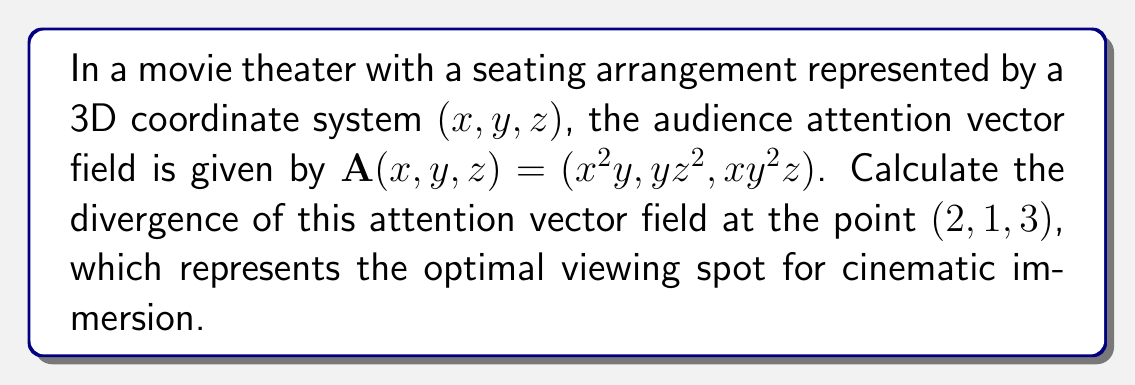What is the answer to this math problem? To solve this problem, we need to calculate the divergence of the given vector field $\mathbf{A}(x,y,z)$ at the point (2, 1, 3). The divergence of a vector field in 3D is defined as:

$$\nabla \cdot \mathbf{A} = \frac{\partial A_x}{\partial x} + \frac{\partial A_y}{\partial y} + \frac{\partial A_z}{\partial z}$$

Where $A_x$, $A_y$, and $A_z$ are the components of the vector field.

Step 1: Identify the components of the vector field:
$A_x = x^2y$
$A_y = yz^2$
$A_z = xy^2z$

Step 2: Calculate the partial derivatives:
$\frac{\partial A_x}{\partial x} = 2xy$
$\frac{\partial A_y}{\partial y} = z^2$
$\frac{\partial A_z}{\partial z} = xy^2$

Step 3: Sum the partial derivatives to get the divergence:
$$\nabla \cdot \mathbf{A} = 2xy + z^2 + xy^2$$

Step 4: Evaluate the divergence at the point (2, 1, 3):
$$\nabla \cdot \mathbf{A}|_{(2,1,3)} = 2(2)(1) + 3^2 + 2(1)^2$$
$$\nabla \cdot \mathbf{A}|_{(2,1,3)} = 4 + 9 + 2 = 15$$

Therefore, the divergence of the audience attention vector field at the optimal viewing spot (2, 1, 3) is 15.
Answer: 15 